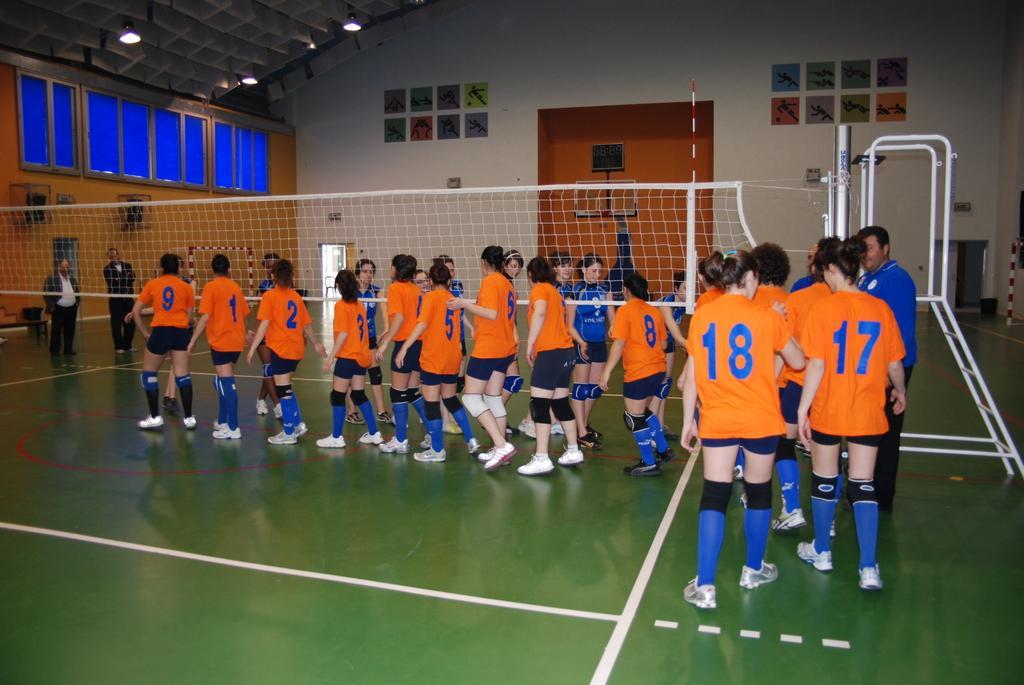In one or two sentences, can you explain what this image depicts? In this picture there are girls in the center of the image, those who are walking in series and there is a net in the center of the image, there are windows and lights on the left side of the image, there are two men on the left side of the image and there are posters on the wall, there is a net in the center of the image. 